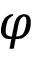Convert formula to latex. <formula><loc_0><loc_0><loc_500><loc_500>\varphi</formula> 